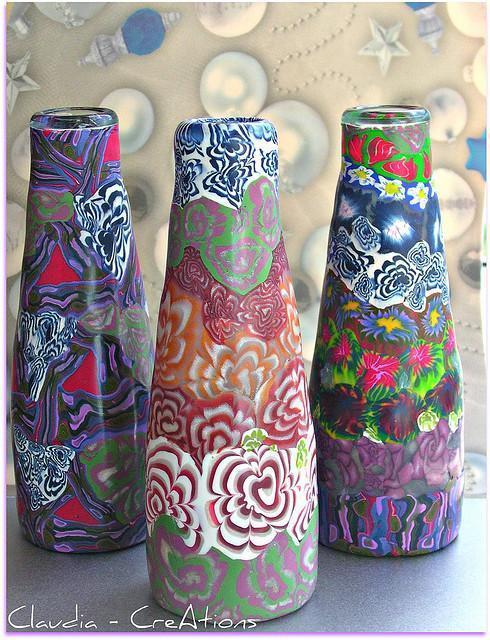How many bottles are there?
Give a very brief answer. 3. How many vases can be seen?
Give a very brief answer. 3. 